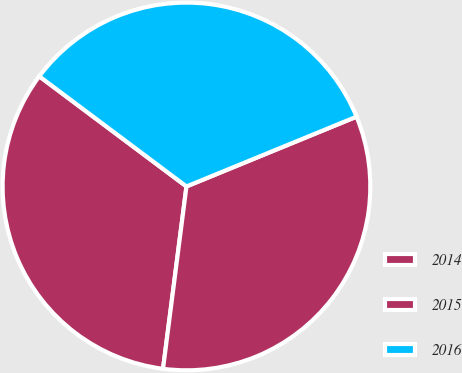Convert chart to OTSL. <chart><loc_0><loc_0><loc_500><loc_500><pie_chart><fcel>2014<fcel>2015<fcel>2016<nl><fcel>33.19%<fcel>33.23%<fcel>33.58%<nl></chart> 